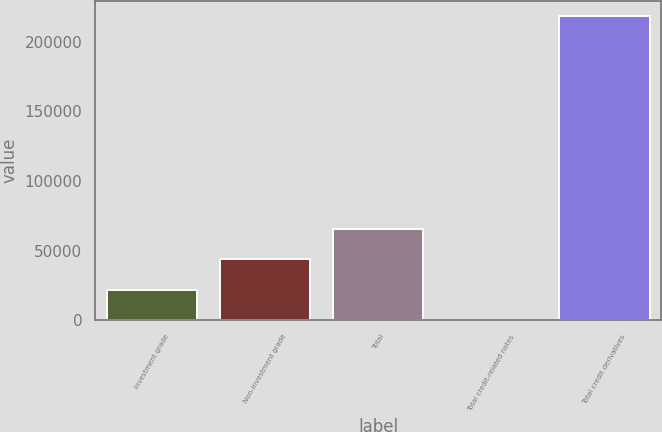<chart> <loc_0><loc_0><loc_500><loc_500><bar_chart><fcel>Investment grade<fcel>Non-investment grade<fcel>Total<fcel>Total credit-related notes<fcel>Total credit derivatives<nl><fcel>21873.6<fcel>43738.2<fcel>65602.8<fcel>9<fcel>218655<nl></chart> 